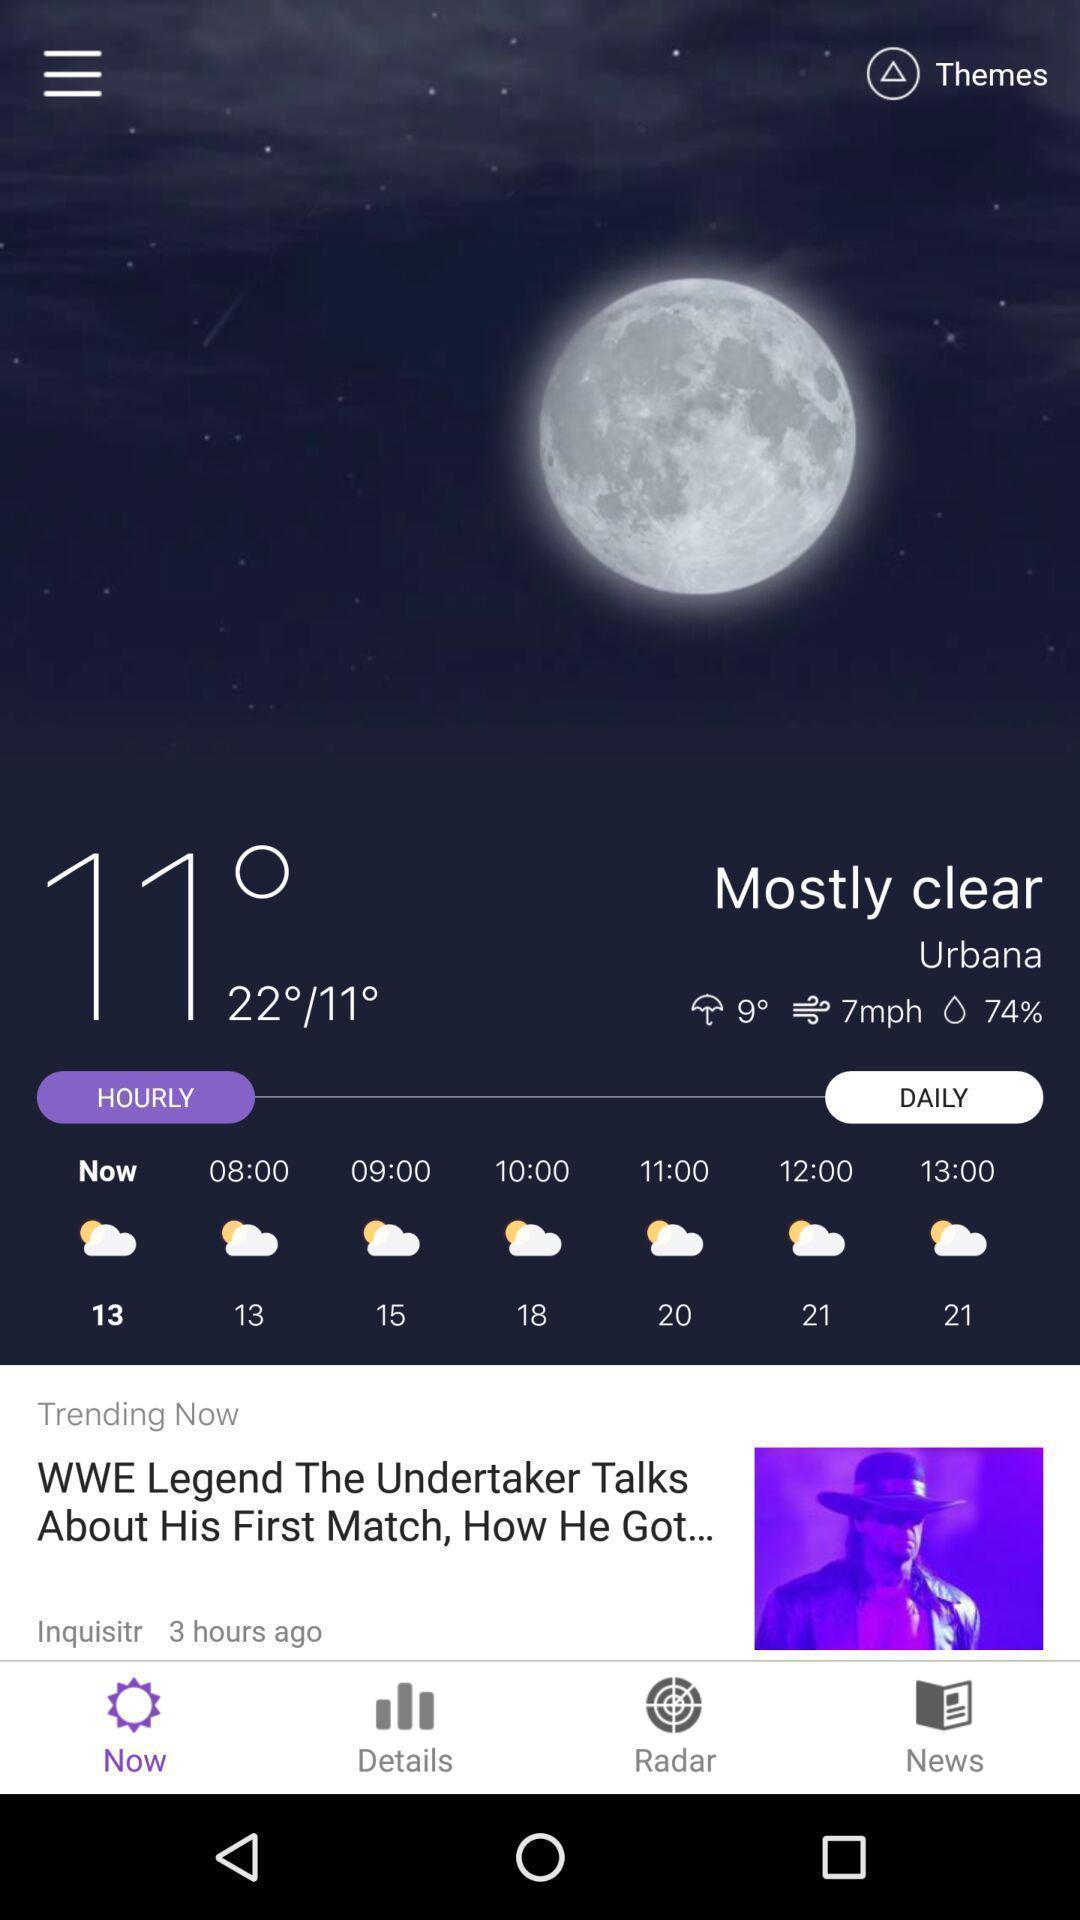What details can you identify in this image? Screen showing weather forecast. 